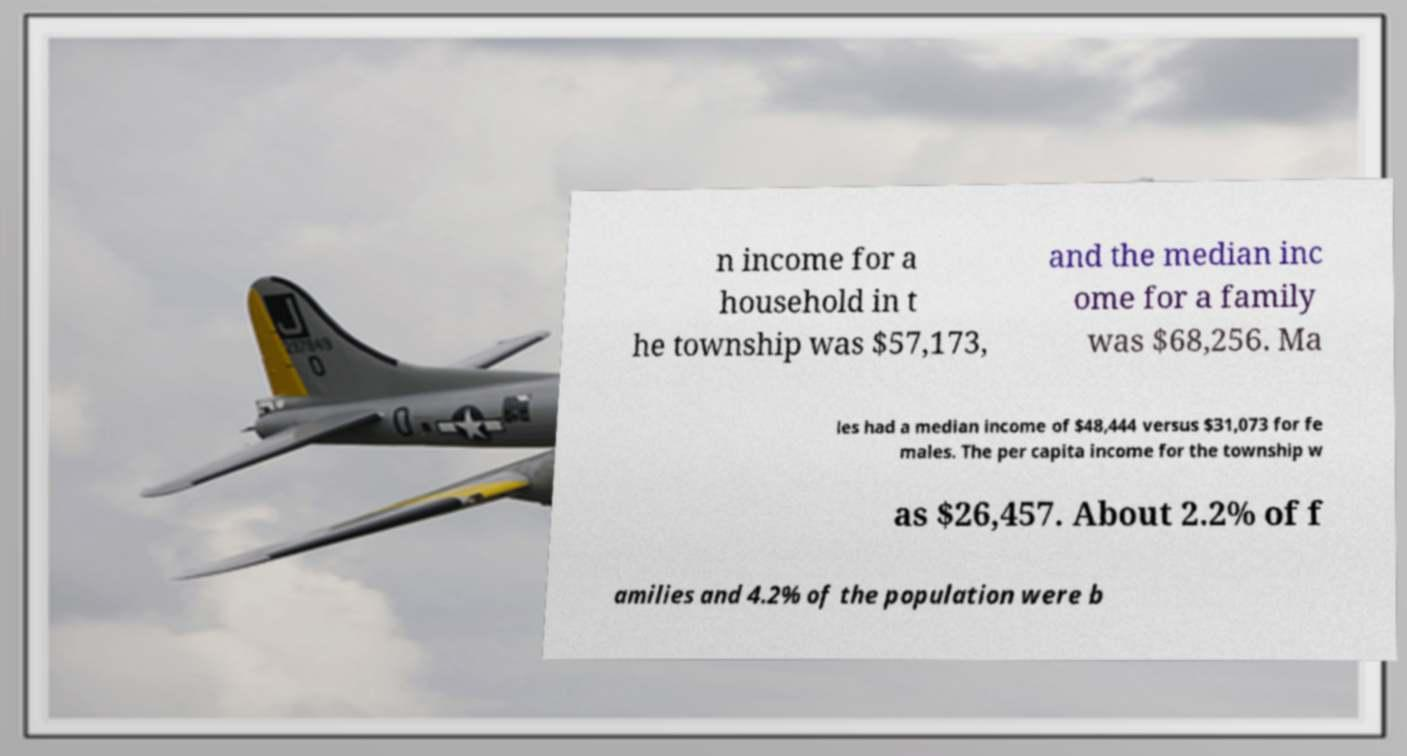What messages or text are displayed in this image? I need them in a readable, typed format. n income for a household in t he township was $57,173, and the median inc ome for a family was $68,256. Ma les had a median income of $48,444 versus $31,073 for fe males. The per capita income for the township w as $26,457. About 2.2% of f amilies and 4.2% of the population were b 